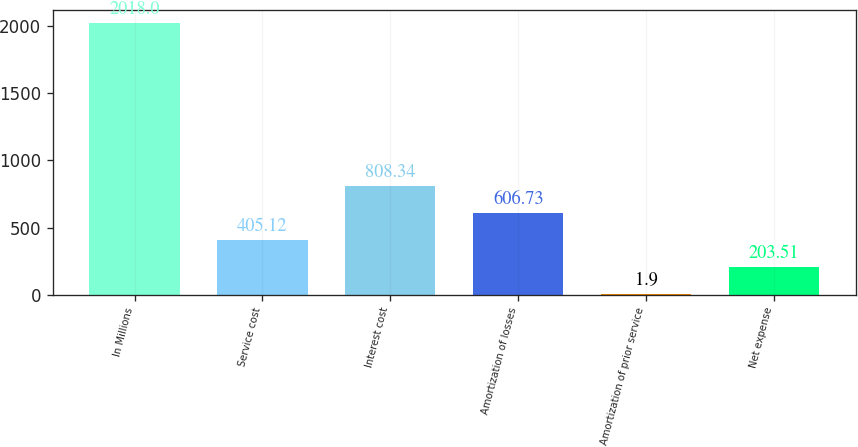Convert chart. <chart><loc_0><loc_0><loc_500><loc_500><bar_chart><fcel>In Millions<fcel>Service cost<fcel>Interest cost<fcel>Amortization of losses<fcel>Amortization of prior service<fcel>Net expense<nl><fcel>2018<fcel>405.12<fcel>808.34<fcel>606.73<fcel>1.9<fcel>203.51<nl></chart> 